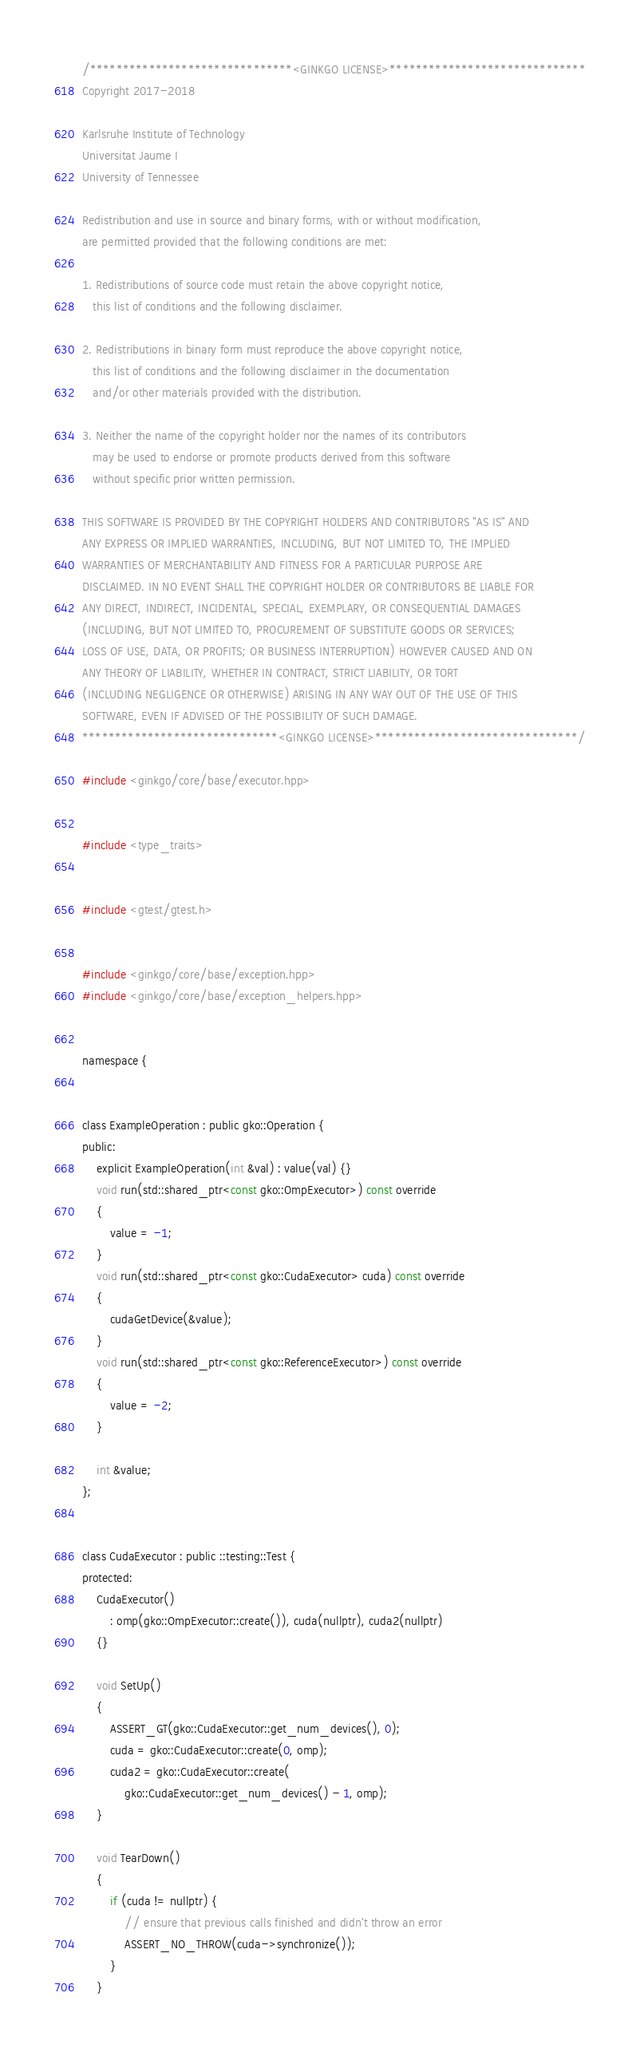Convert code to text. <code><loc_0><loc_0><loc_500><loc_500><_Cuda_>/*******************************<GINKGO LICENSE>******************************
Copyright 2017-2018

Karlsruhe Institute of Technology
Universitat Jaume I
University of Tennessee

Redistribution and use in source and binary forms, with or without modification,
are permitted provided that the following conditions are met:

1. Redistributions of source code must retain the above copyright notice,
   this list of conditions and the following disclaimer.

2. Redistributions in binary form must reproduce the above copyright notice,
   this list of conditions and the following disclaimer in the documentation
   and/or other materials provided with the distribution.

3. Neither the name of the copyright holder nor the names of its contributors
   may be used to endorse or promote products derived from this software
   without specific prior written permission.

THIS SOFTWARE IS PROVIDED BY THE COPYRIGHT HOLDERS AND CONTRIBUTORS "AS IS" AND
ANY EXPRESS OR IMPLIED WARRANTIES, INCLUDING, BUT NOT LIMITED TO, THE IMPLIED
WARRANTIES OF MERCHANTABILITY AND FITNESS FOR A PARTICULAR PURPOSE ARE
DISCLAIMED. IN NO EVENT SHALL THE COPYRIGHT HOLDER OR CONTRIBUTORS BE LIABLE FOR
ANY DIRECT, INDIRECT, INCIDENTAL, SPECIAL, EXEMPLARY, OR CONSEQUENTIAL DAMAGES
(INCLUDING, BUT NOT LIMITED TO, PROCUREMENT OF SUBSTITUTE GOODS OR SERVICES;
LOSS OF USE, DATA, OR PROFITS; OR BUSINESS INTERRUPTION) HOWEVER CAUSED AND ON
ANY THEORY OF LIABILITY, WHETHER IN CONTRACT, STRICT LIABILITY, OR TORT
(INCLUDING NEGLIGENCE OR OTHERWISE) ARISING IN ANY WAY OUT OF THE USE OF THIS
SOFTWARE, EVEN IF ADVISED OF THE POSSIBILITY OF SUCH DAMAGE.
******************************<GINKGO LICENSE>*******************************/

#include <ginkgo/core/base/executor.hpp>


#include <type_traits>


#include <gtest/gtest.h>


#include <ginkgo/core/base/exception.hpp>
#include <ginkgo/core/base/exception_helpers.hpp>


namespace {


class ExampleOperation : public gko::Operation {
public:
    explicit ExampleOperation(int &val) : value(val) {}
    void run(std::shared_ptr<const gko::OmpExecutor>) const override
    {
        value = -1;
    }
    void run(std::shared_ptr<const gko::CudaExecutor> cuda) const override
    {
        cudaGetDevice(&value);
    }
    void run(std::shared_ptr<const gko::ReferenceExecutor>) const override
    {
        value = -2;
    }

    int &value;
};


class CudaExecutor : public ::testing::Test {
protected:
    CudaExecutor()
        : omp(gko::OmpExecutor::create()), cuda(nullptr), cuda2(nullptr)
    {}

    void SetUp()
    {
        ASSERT_GT(gko::CudaExecutor::get_num_devices(), 0);
        cuda = gko::CudaExecutor::create(0, omp);
        cuda2 = gko::CudaExecutor::create(
            gko::CudaExecutor::get_num_devices() - 1, omp);
    }

    void TearDown()
    {
        if (cuda != nullptr) {
            // ensure that previous calls finished and didn't throw an error
            ASSERT_NO_THROW(cuda->synchronize());
        }
    }
</code> 